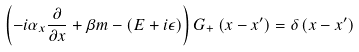<formula> <loc_0><loc_0><loc_500><loc_500>\left ( - i \alpha _ { x } \frac { \partial } { \partial x } + \beta m - \left ( E + i \epsilon \right ) \right ) G _ { + } \left ( x - x ^ { \prime } \right ) = \delta \left ( x - x ^ { \prime } \right ) \,</formula> 